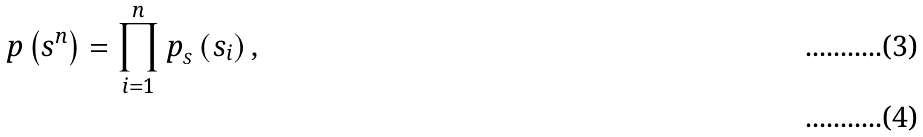Convert formula to latex. <formula><loc_0><loc_0><loc_500><loc_500>p \left ( s ^ { n } \right ) = \prod _ { i = 1 } ^ { n } p _ { _ { S } } \left ( s _ { i } \right ) , \\</formula> 